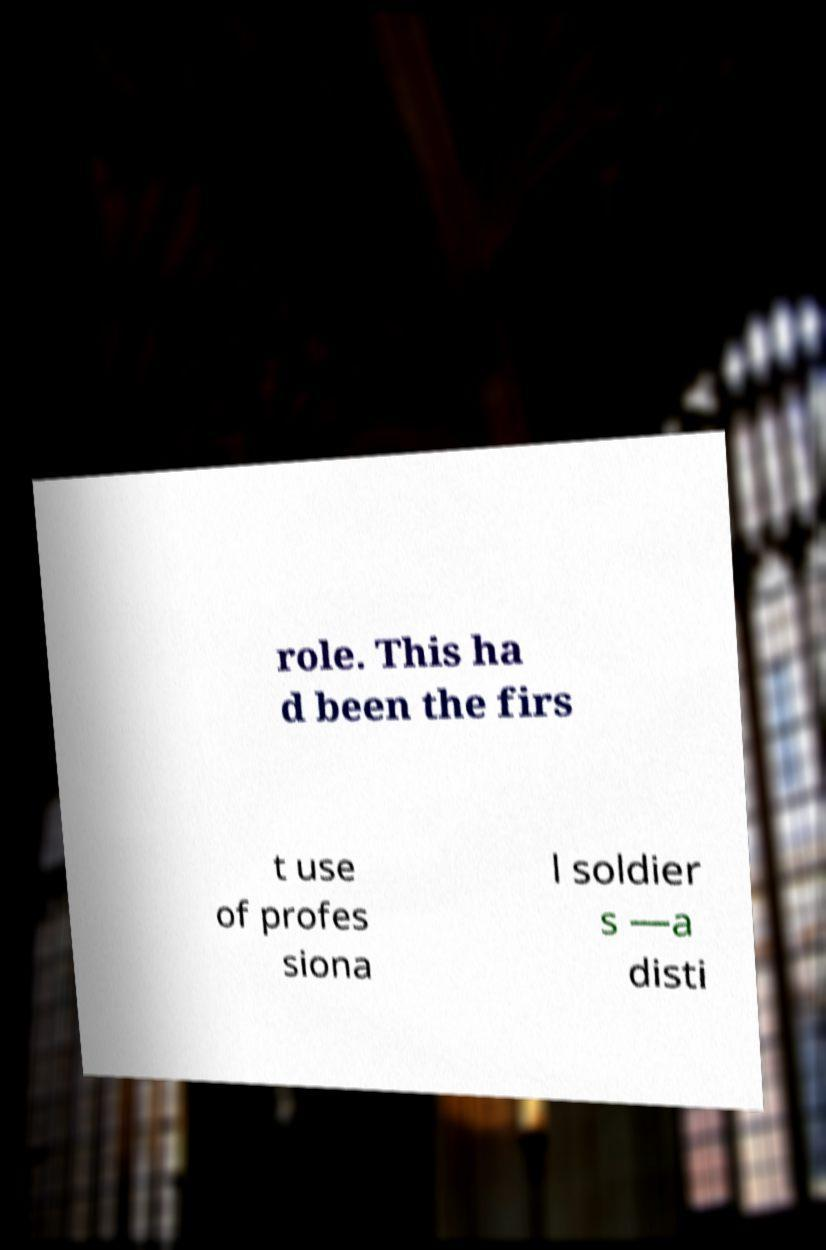Please read and relay the text visible in this image. What does it say? role. This ha d been the firs t use of profes siona l soldier s —a disti 